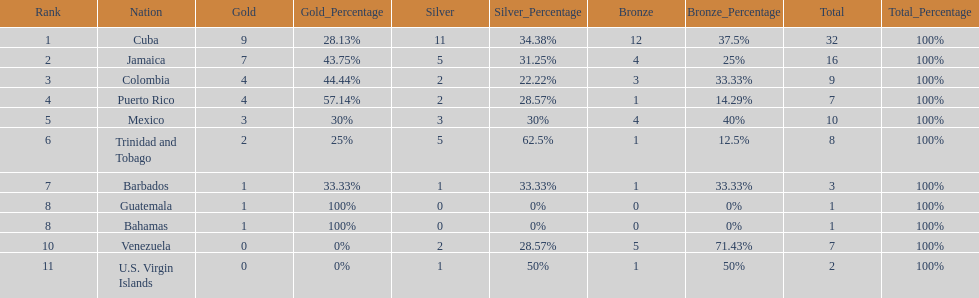What is the total number of gold medals awarded between these 11 countries? 32. 